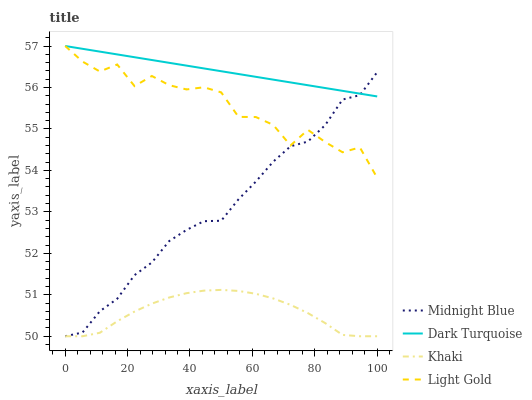Does Khaki have the minimum area under the curve?
Answer yes or no. Yes. Does Dark Turquoise have the maximum area under the curve?
Answer yes or no. Yes. Does Light Gold have the minimum area under the curve?
Answer yes or no. No. Does Light Gold have the maximum area under the curve?
Answer yes or no. No. Is Dark Turquoise the smoothest?
Answer yes or no. Yes. Is Light Gold the roughest?
Answer yes or no. Yes. Is Khaki the smoothest?
Answer yes or no. No. Is Khaki the roughest?
Answer yes or no. No. Does Khaki have the lowest value?
Answer yes or no. Yes. Does Light Gold have the lowest value?
Answer yes or no. No. Does Light Gold have the highest value?
Answer yes or no. Yes. Does Khaki have the highest value?
Answer yes or no. No. Is Khaki less than Dark Turquoise?
Answer yes or no. Yes. Is Dark Turquoise greater than Khaki?
Answer yes or no. Yes. Does Light Gold intersect Dark Turquoise?
Answer yes or no. Yes. Is Light Gold less than Dark Turquoise?
Answer yes or no. No. Is Light Gold greater than Dark Turquoise?
Answer yes or no. No. Does Khaki intersect Dark Turquoise?
Answer yes or no. No. 